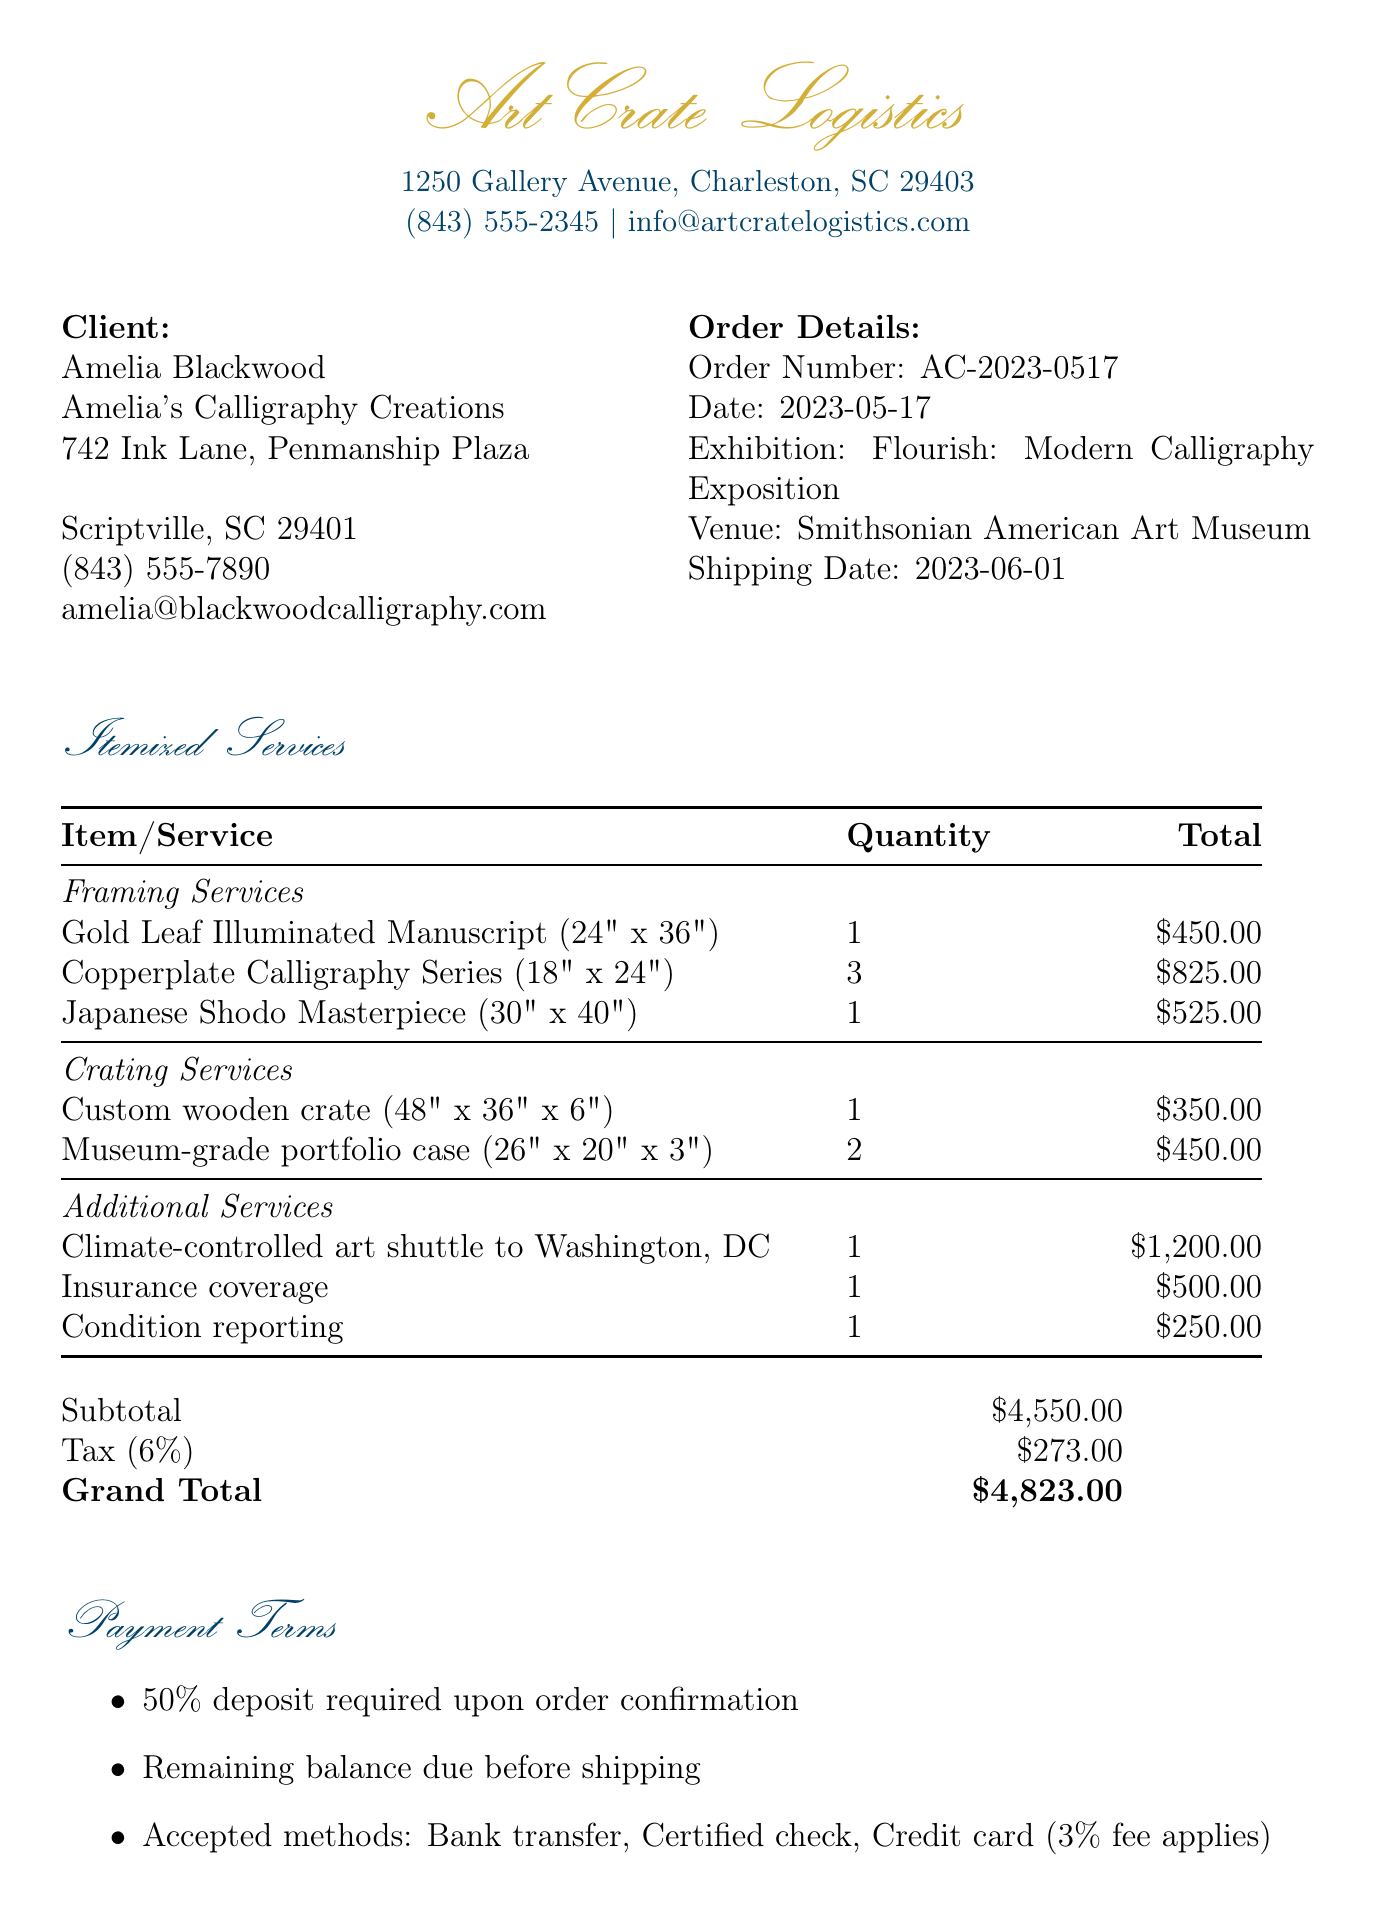What is the client’s name? The client's name is stated at the beginning of the document under client info.
Answer: Amelia Blackwood What is the exhibition venue? The venue for the exhibition is listed under order details.
Answer: Smithsonian American Art Museum What is the total amount subject to tax? The subtotal before tax is identified in the totals section as the sum of all services rendered.
Answer: 4550.00 How many pieces are in the Copperplate Calligraphy Series? The quantity of the Copperplate Calligraphy Series is specified in the framing services section.
Answer: 3 What type of shipping service is provided? The specific shipping service offered is mentioned in the additional services section.
Answer: Climate-controlled art shuttle to Washington, DC What is the total cost of framing services? The total for framing services is summed up and presented in the totals section of the document.
Answer: 1800.00 What is the deposit required upon order confirmation? The deposit requirement is detailed under payment terms in the document.
Answer: 50% What is the description of the insurance coverage? The nature of the insurance coverage is defined in the additional services section.
Answer: Full-value coverage for artworks during transit What are the accepted payment methods? The accepted payment methods are listed under payment terms in the document and include various options.
Answer: Bank transfer, Certified check, Credit card (3% fee applies) 